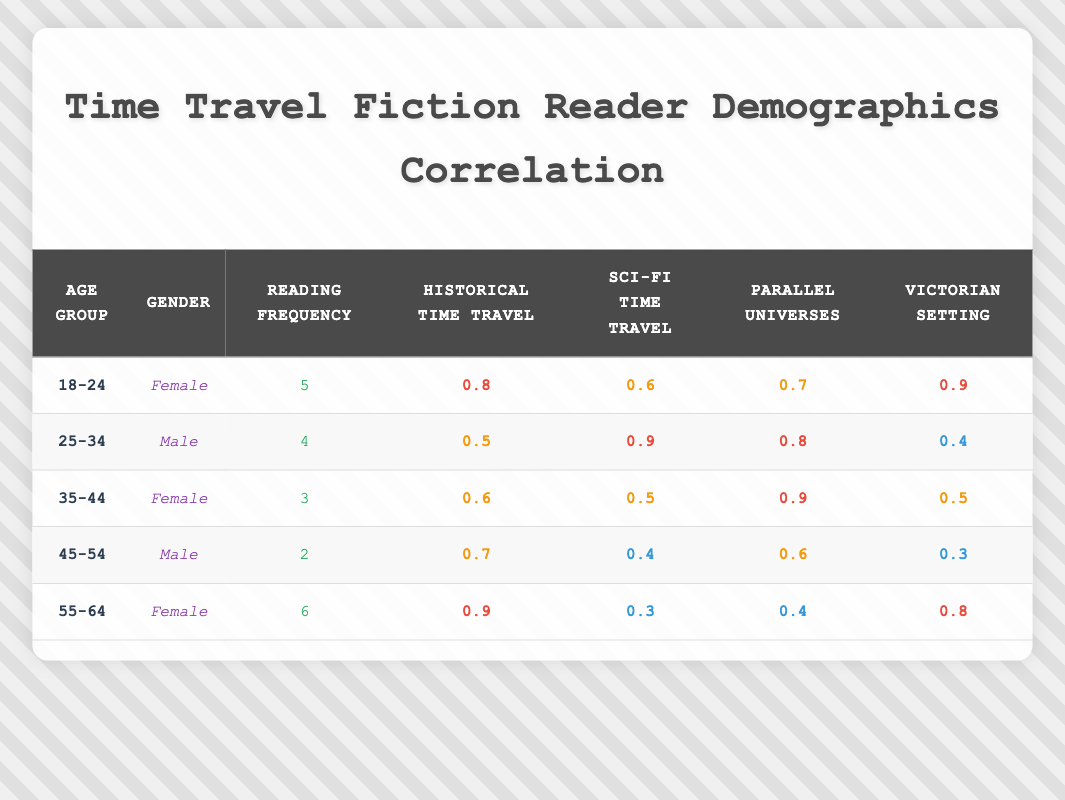What age group has the highest preference for historical time travel? Looking at the "Historical Time Travel" column, the age group "55-64" has the highest preference at 0.9.
Answer: 55-64 Which gender shows a preference for science fiction time travel in the 25-34 age group? In the table, the 25-34 age group with gender "Male" has a preference score of 0.9 for science fiction time travel.
Answer: Male What is the average frequency of reading for females in the age groups presented? The frequencies for females are 5 (18-24), 3 (35-44), and 6 (55-64). To find the average, we sum these values (5 + 3 + 6 = 14) and divide by the number of data points (3). The average frequency is 14/3 = 4.67.
Answer: 4.67 Is there a preference for time travel with a Victorian setting higher than 0.5 among any age groups? Examining the "Victorian Setting" column, we find that the age groups 18-24 (0.9) and 55-64 (0.8) both have a preference higher than 0.5.
Answer: Yes What is the difference in the preference for parallel universes between the 35-44 age group and the 45-54 age group? The preference for parallel universes for the 35-44 age group is 0.9, while for the 45-54 age group, it is 0.6. The difference is thus 0.9 - 0.6 = 0.3.
Answer: 0.3 Do males have a higher average preference for historical time travel compared to females? The preferences for historical time travel for males are 0.5 (25-34) and 0.7 (45-54), averaging (0.5 + 0.7)/2 = 0.6. For females, the preferences are 0.8 (18-24), 0.6 (35-44), and 0.9 (55-64), averaging (0.8 + 0.6 + 0.9)/3 = 0.7667. Since 0.6 < 0.7667, males do not have a higher average.
Answer: No What is the highest preference for time travel with a Victorian setting across all age groups? The "Victorian Setting" column shows that the highest preference is 0.9 for the 18-24 age group.
Answer: 0.9 Which age group has the least frequency of reading? From the "Reading Frequency" column, the age group with the least reading frequency is 45-54, with a score of 2.
Answer: 45-54 How many age groups have a preference for science fiction time travel below 0.5? In the "Sci-Fi Time Travel" column, only the 45-54 age group has a preference below 0.5 (0.4). Therefore, the total number of age groups with such a preference is one.
Answer: 1 